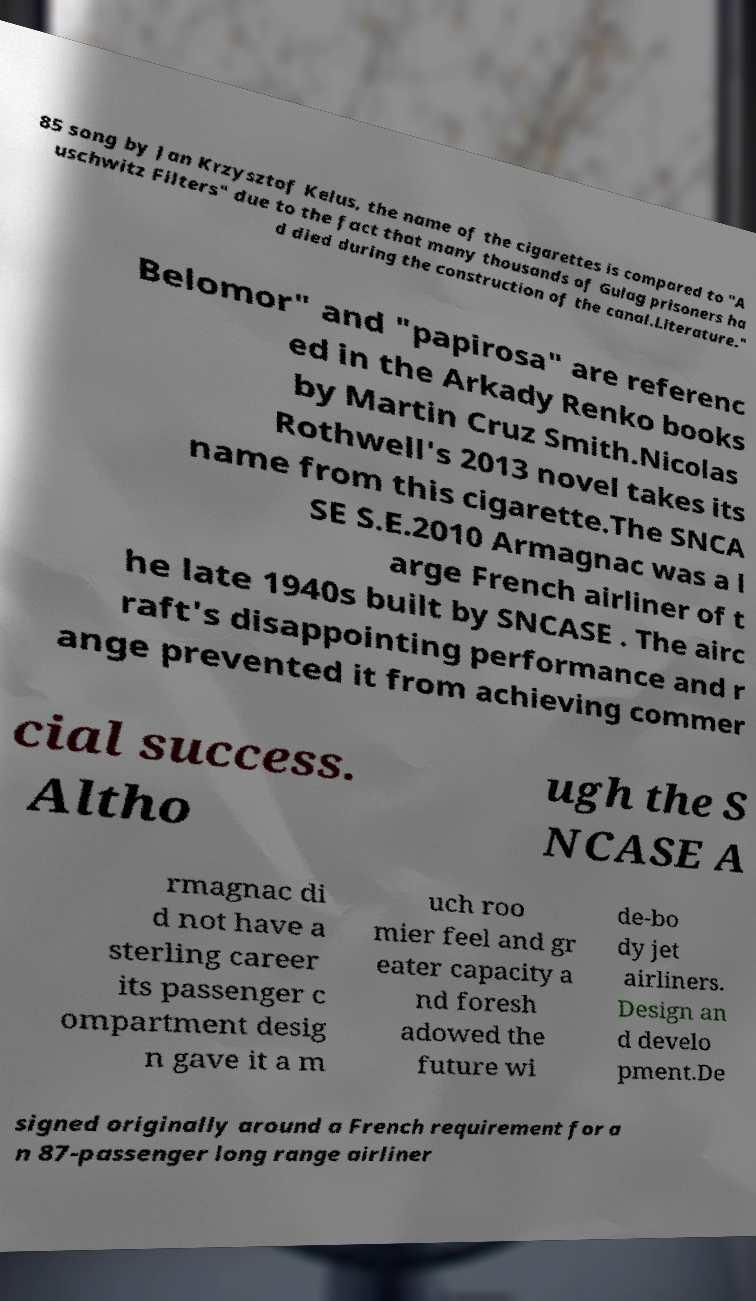Please identify and transcribe the text found in this image. 85 song by Jan Krzysztof Kelus, the name of the cigarettes is compared to "A uschwitz Filters" due to the fact that many thousands of Gulag prisoners ha d died during the construction of the canal.Literature." Belomor" and "papirosa" are referenc ed in the Arkady Renko books by Martin Cruz Smith.Nicolas Rothwell's 2013 novel takes its name from this cigarette.The SNCA SE S.E.2010 Armagnac was a l arge French airliner of t he late 1940s built by SNCASE . The airc raft's disappointing performance and r ange prevented it from achieving commer cial success. Altho ugh the S NCASE A rmagnac di d not have a sterling career its passenger c ompartment desig n gave it a m uch roo mier feel and gr eater capacity a nd foresh adowed the future wi de-bo dy jet airliners. Design an d develo pment.De signed originally around a French requirement for a n 87-passenger long range airliner 